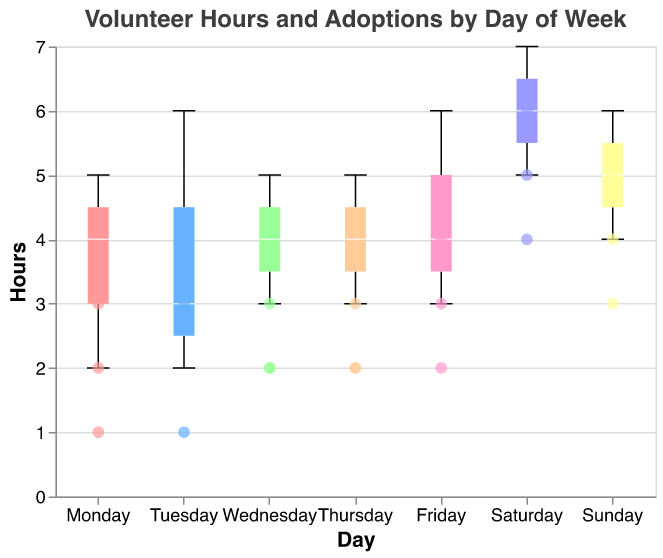What is the title of the figure? The title is located at the top of the figure and reads "Volunteer Hours and Adoptions by Day of Week".
Answer: Volunteer Hours and Adoptions by Day of Week Which day has the highest median volunteer hours? By examining the notched box plots, the highest median bar is observed on "Saturday".
Answer: Saturday What is the range of volunteer hours on Monday? The box plot for Monday shows the minimum value at 2 hours and the maximum value at 5 hours.
Answer: 2 to 5 hours On which day do volunteers spend the most time on average? By comparing the box plots, Saturday stands out with higher average hours, visible from its larger interquartile range and median.
Answer: Saturday What is the median number of adoptions on Sunday? The points representing adoptions on Sunday generally hover around 4 adoptions, indicating the median.
Answer: 4 How do volunteer hours on weekdays (Monday to Friday) compare to weekends (Saturday and Sunday)? Weekdays display a varied range from low to moderate hours, while weekends show significantly higher volunteer hours, particularly on Saturday.
Answer: Weekdays have lower hours, weekends have higher hours What day appears to have the most variability in volunteer hours? Reviewing the width of the box plots (interquartile ranges), Tuesday exhibits the most variability as it spans a wide range of hours.
Answer: Tuesday Is there a notable difference in the number of adoptions between weekdays and weekends? Points representing adoptions are generally higher on weekends as compared to weekdays, with higher values grouped on Saturday and Sunday.
Answer: Yes, weekends have higher adoptions How many volunteer hours are there on average during the weekend (Saturday and Sunday)? Summing the hours for Saturday (6, 7, 5) and Sunday (4, 6, 5), and then dividing by the total number of entries (6), we get (6+7+5+4+6+5)/6 = 33/6 ≈ 5.5 hours.
Answer: About 5.5 hours Which day has the smallest number of outliers for volunteer hours? Observing the notched box plots reveals that Thursday shows no evident outliers beyond the whiskers.
Answer: Thursday 